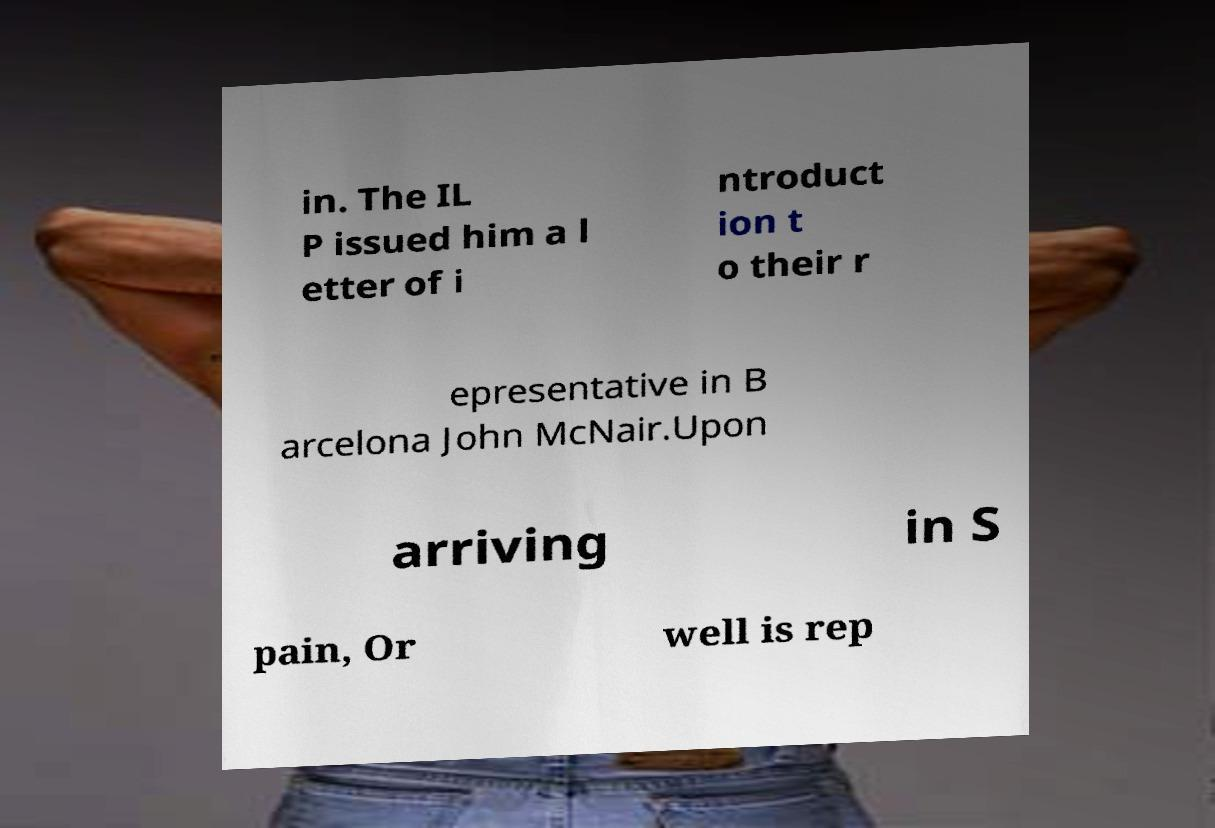Please identify and transcribe the text found in this image. in. The IL P issued him a l etter of i ntroduct ion t o their r epresentative in B arcelona John McNair.Upon arriving in S pain, Or well is rep 